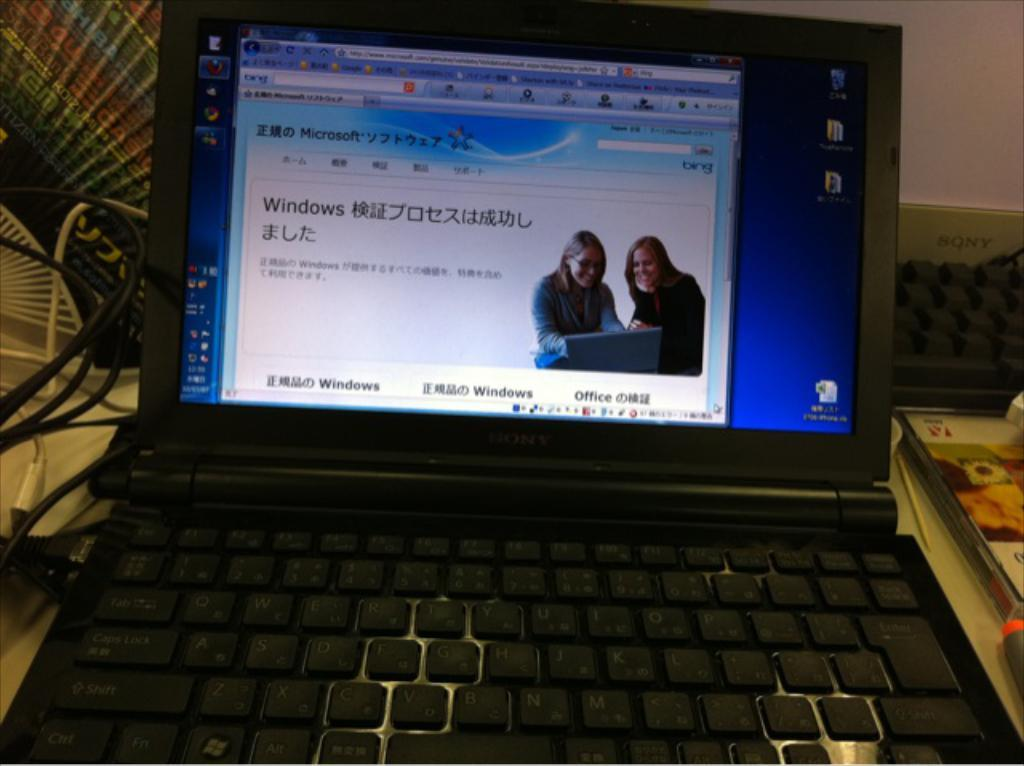<image>
Render a clear and concise summary of the photo. The laptop has windows as well as foreign language on the screen. 